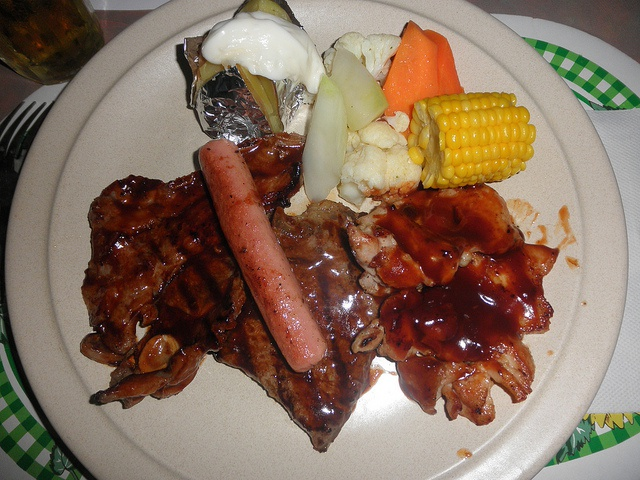Describe the objects in this image and their specific colors. I can see hot dog in black, brown, and maroon tones, carrot in black, red, brown, and tan tones, and fork in black and gray tones in this image. 